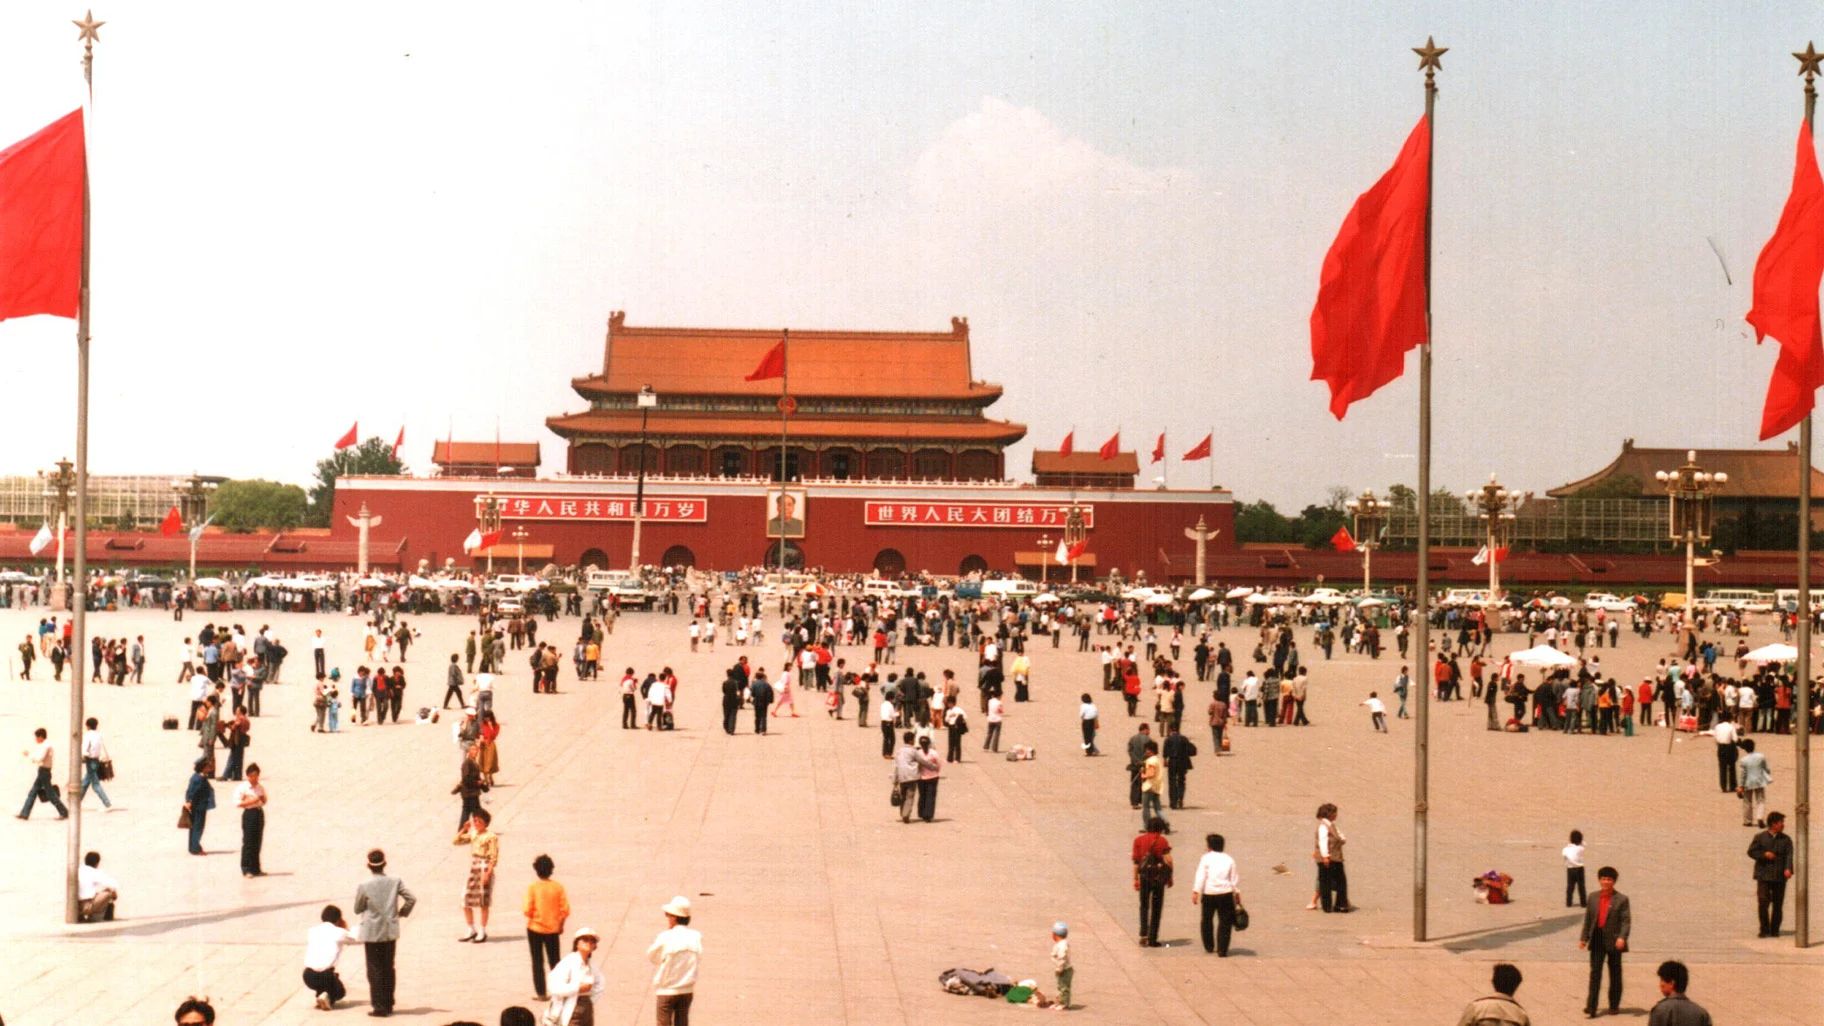How do locals typically use this space on regular days? On regular days, Tiananmen Square is a popular spot for both locals and tourists. Locals often visit the square for leisurely strolls, to meet with friends, or to practice tai chi in the morning. It is also a common place for official gatherings and national celebrations. The square's vast open space makes it an ideal location for various activities and events, reflecting the communal and public nature of this iconic landmark. 